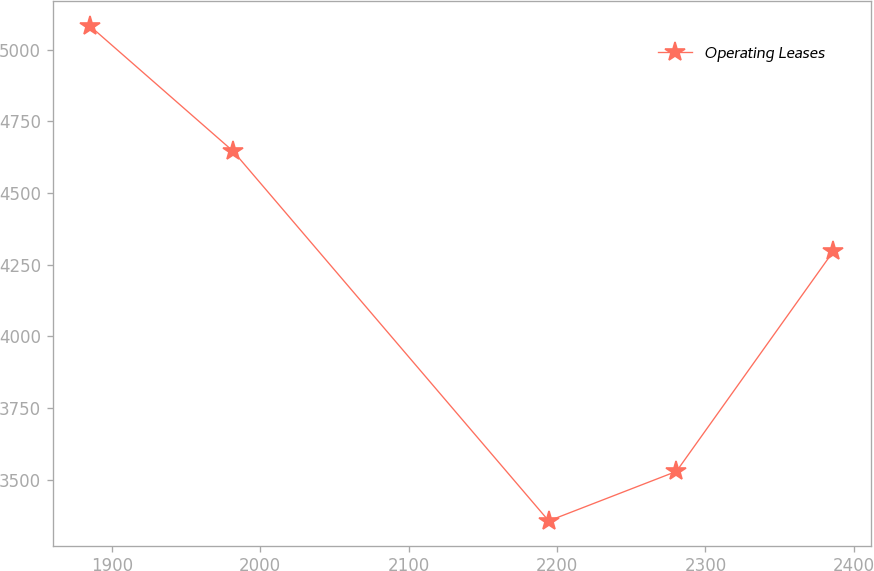<chart> <loc_0><loc_0><loc_500><loc_500><line_chart><ecel><fcel>Operating Leases<nl><fcel>1885.25<fcel>5082.67<nl><fcel>1981.95<fcel>4644.89<nl><fcel>2194.4<fcel>3356.66<nl><fcel>2280.44<fcel>3529.26<nl><fcel>2386.15<fcel>4296.73<nl></chart> 